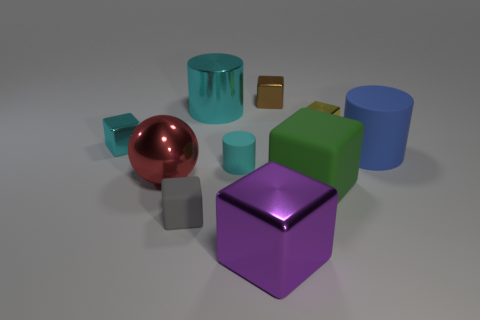Subtract all big cylinders. How many cylinders are left? 1 Subtract all yellow cubes. How many cubes are left? 5 Subtract all red cubes. Subtract all yellow cylinders. How many cubes are left? 6 Subtract all spheres. How many objects are left? 9 Add 4 large balls. How many large balls exist? 5 Subtract 0 red cubes. How many objects are left? 10 Subtract all big yellow objects. Subtract all big cyan metal cylinders. How many objects are left? 9 Add 2 small metallic cubes. How many small metallic cubes are left? 5 